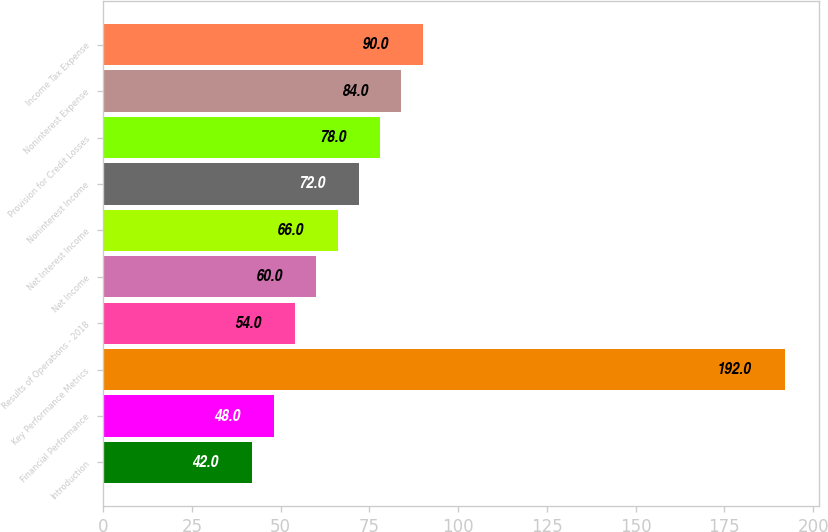Convert chart. <chart><loc_0><loc_0><loc_500><loc_500><bar_chart><fcel>Introduction<fcel>Financial Performance<fcel>Key Performance Metrics<fcel>Results of Operations - 2018<fcel>Net Income<fcel>Net Interest Income<fcel>Noninterest Income<fcel>Provision for Credit Losses<fcel>Noninterest Expense<fcel>Income Tax Expense<nl><fcel>42<fcel>48<fcel>192<fcel>54<fcel>60<fcel>66<fcel>72<fcel>78<fcel>84<fcel>90<nl></chart> 